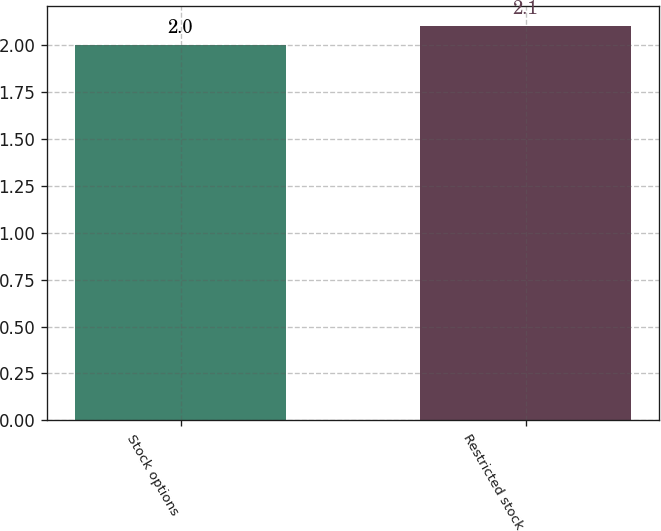<chart> <loc_0><loc_0><loc_500><loc_500><bar_chart><fcel>Stock options<fcel>Restricted stock<nl><fcel>2<fcel>2.1<nl></chart> 